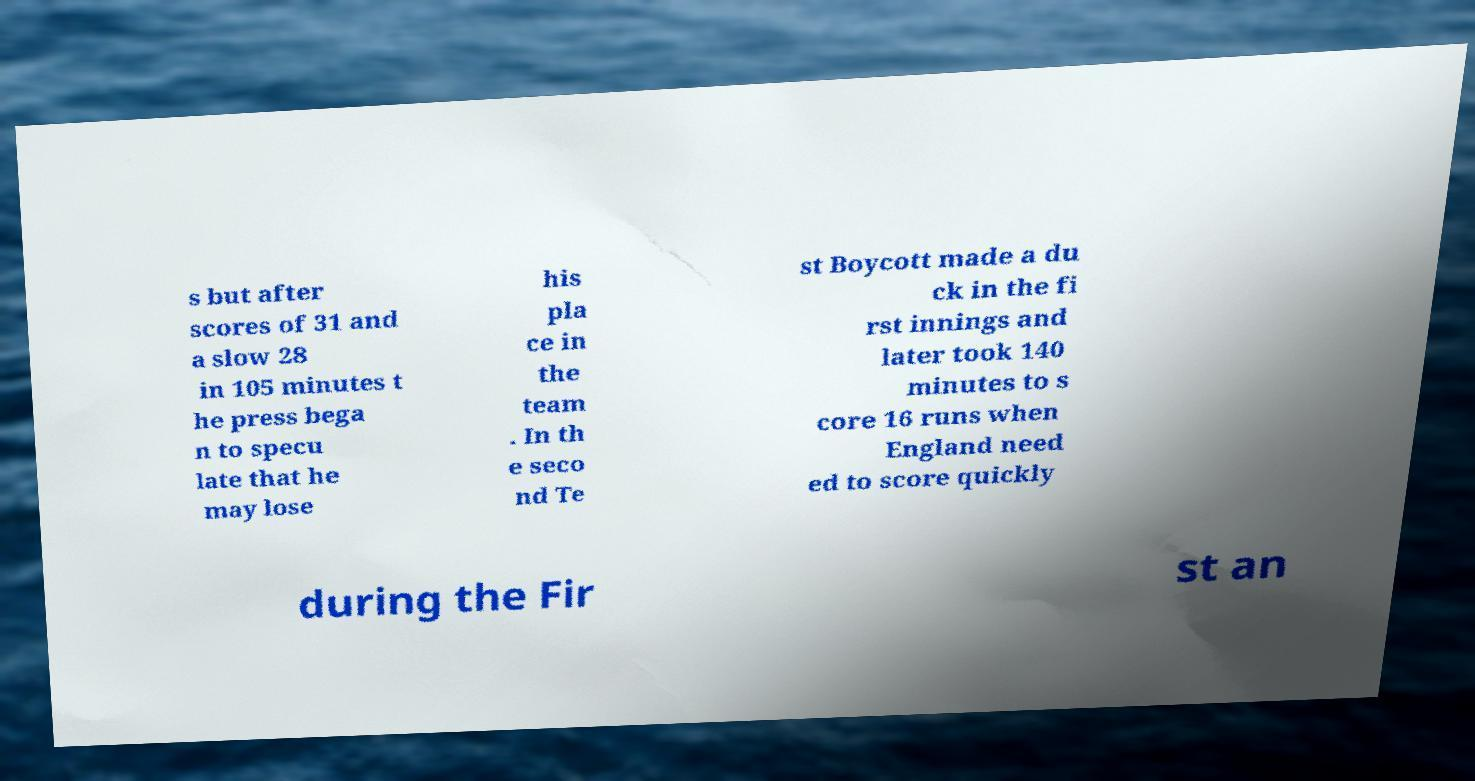Please identify and transcribe the text found in this image. s but after scores of 31 and a slow 28 in 105 minutes t he press bega n to specu late that he may lose his pla ce in the team . In th e seco nd Te st Boycott made a du ck in the fi rst innings and later took 140 minutes to s core 16 runs when England need ed to score quickly during the Fir st an 